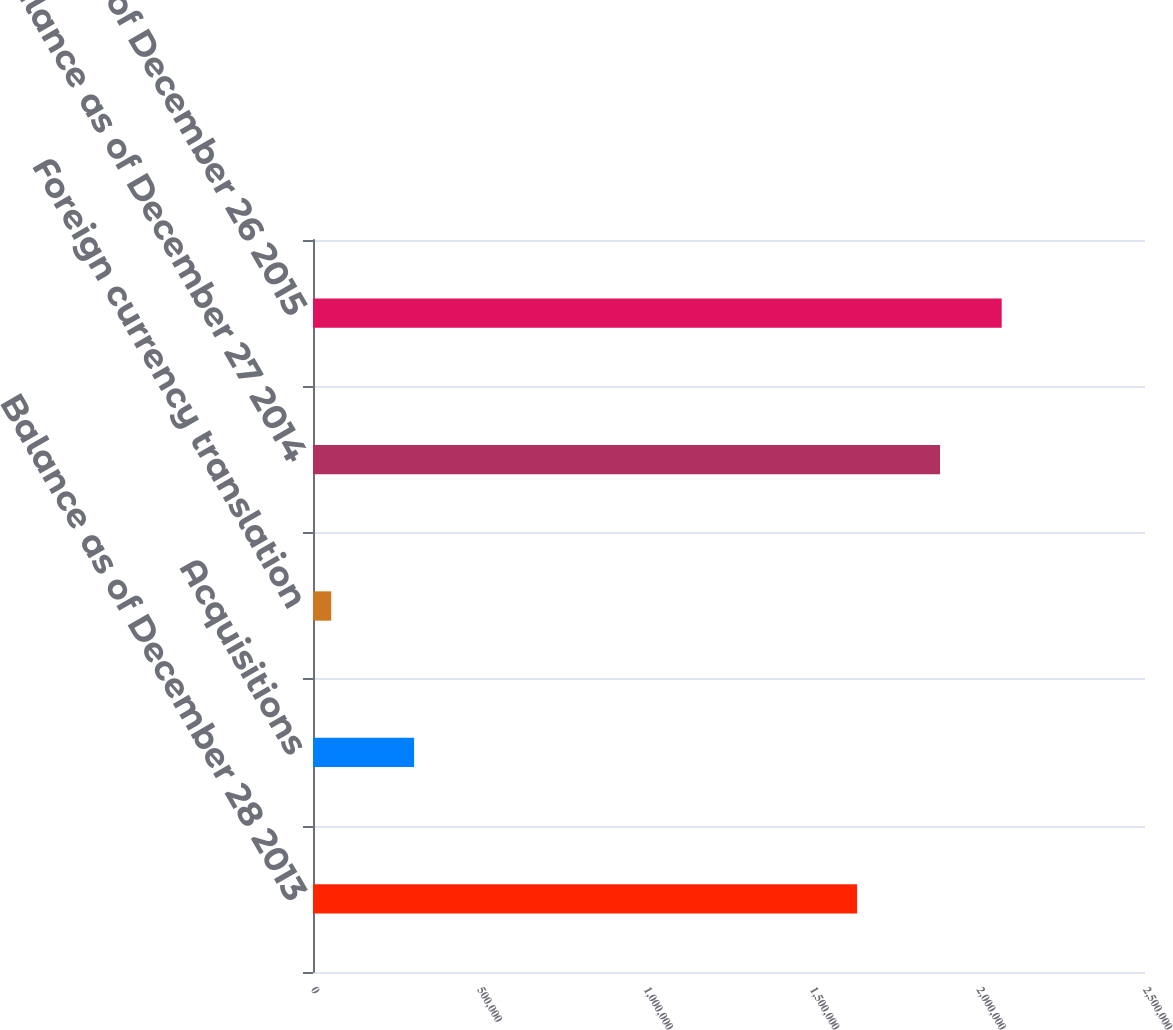Convert chart. <chart><loc_0><loc_0><loc_500><loc_500><bar_chart><fcel>Balance as of December 28 2013<fcel>Acquisitions<fcel>Foreign currency translation<fcel>Balance as of December 27 2014<fcel>Balance as of December 26 2015<nl><fcel>1.635e+06<fcel>303857<fcel>54739<fcel>1.88412e+06<fcel>2.06941e+06<nl></chart> 